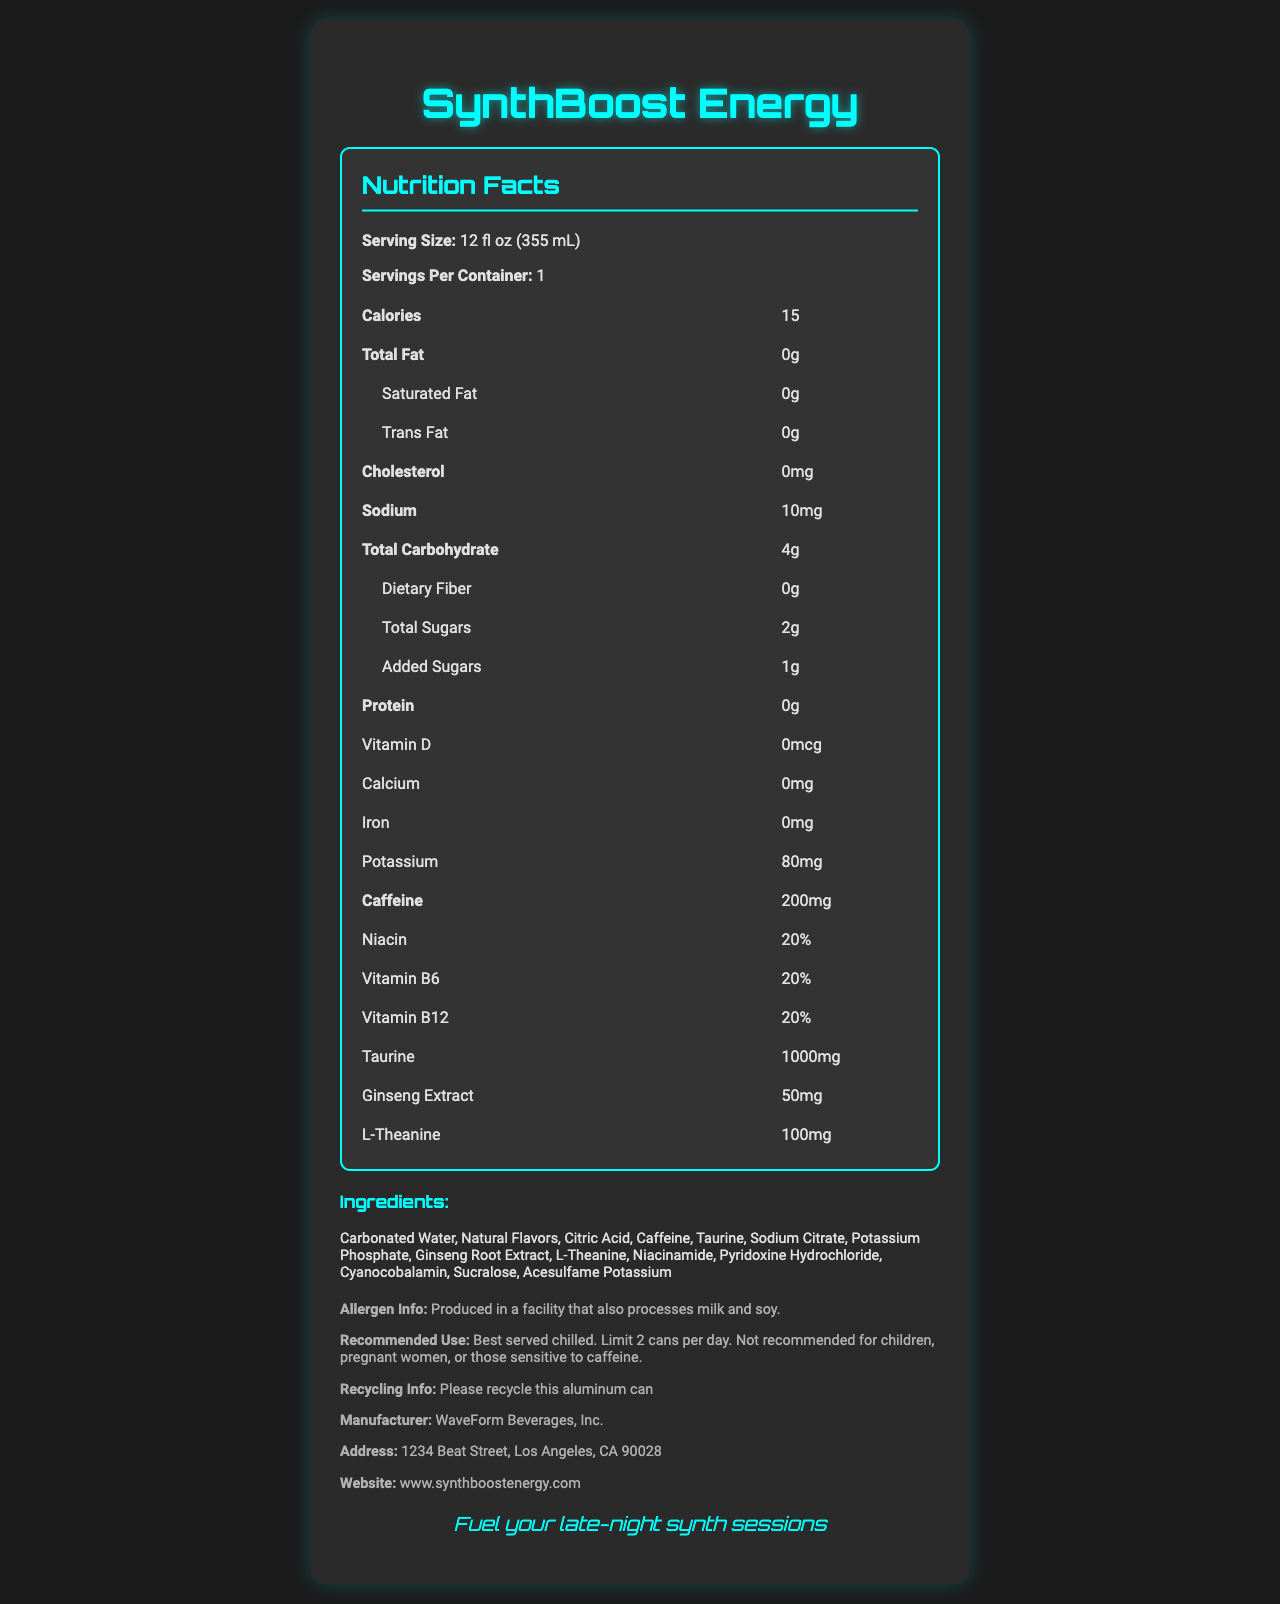what is the product name? The product name is mentioned at the top of the document and emphasized with a bold and larger font size.
Answer: SynthBoost Energy how many calories per serving are in SynthBoost Energy? The number of calories per serving is listed under the nutrition facts section as "Calories: 15".
Answer: 15 how much potassium is in one serving of SynthBoost Energy? The amount of potassium per serving is listed in the nutrition facts under the section for micro-nutrients: "Potassium: 80 mg".
Answer: 80 mg how much caffeine does SynthBoost Energy contain per serving? The amount of caffeine is prominently listed under the nutrition facts: "Caffeine: 200 mg".
Answer: 200 mg what is the recommended use for SynthBoost Energy? The recommended use information is detailed in the additional info section under "Recommended Use".
Answer: Best served chilled. Limit 2 cans per day. Not recommended for children, pregnant women, or those sensitive to caffeine. which ingredient is NOT found in SynthBoost Energy? A. Taurine B. Caffeine C. High Fructose Corn Syrup D. Sucralose High Fructose Corn Syrup is not listed among the ingredients mentioned in the document.
Answer: C. High Fructose Corn Syrup how many servings are in one container of SynthBoost Energy? A. 1 B. 2 C. 3 D. 4 The document states that the number of servings per container is 1 under the nutrition facts section.
Answer: A. 1 is SynthBoost Energy recommended for pregnant women? The recommended use section specifies that the product is not recommended for pregnant women.
Answer: No summarize the main purpose of SynthBoost Energy. SynthBoost Energy is specially formulated to support long and creative work sessions with its blend of caffeine and other performance-enhancing ingredients, as detailed in the product description and nutrition facts.
Answer: SynthBoost Energy is a low-calorie, high-caffeine beverage designed for electronic music producers. It aims to provide a focused energy boost without a sugar crash, helping users maintain alertness and enhance creativity during studio sessions. The drink contains additional B-vitamins, taurine, ginseng extract, and L-theanine. what is the amount of niacin present in SynthBoost Energy? The presence of niacin is listed under the micro-nutrients section as "Niacin: 20%".
Answer: 20% what flavors are used in SynthBoost Energy? The ingredients section specifically lists "Natural Flavors" as one of the components.
Answer: Natural Flavors who manufactures SynthBoost Energy? The manufacturer information is provided in the additional info section: "Manufacturer: WaveForm Beverages, Inc."
Answer: WaveForm Beverages, Inc. how many grams of total sugars are in SynthBoost Energy? The total sugars content is listed in the nutrition facts section under the carbohydrate breakdown: "Total Sugars: 2g".
Answer: 2 grams is the nutritional label addressable from the document? The document does not include any interface or marker indicating that the nutritional label itself can be directly addressed or clicked.
Answer: Not enough information 